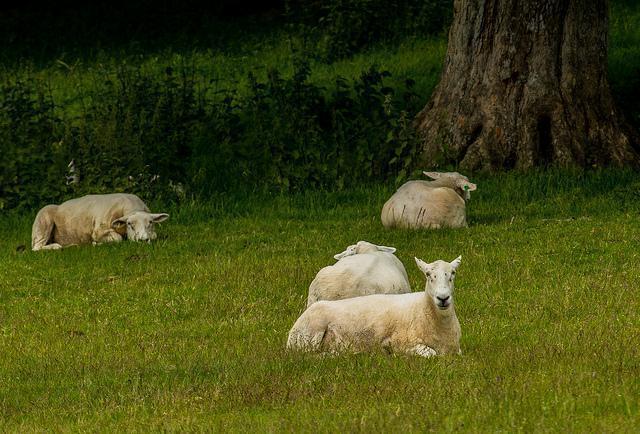How many pairs of ears do you see?
Give a very brief answer. 4. How many sheep are laying in the field?
Give a very brief answer. 4. How many animals are in the photo?
Give a very brief answer. 4. How many sheep can you see?
Give a very brief answer. 4. 